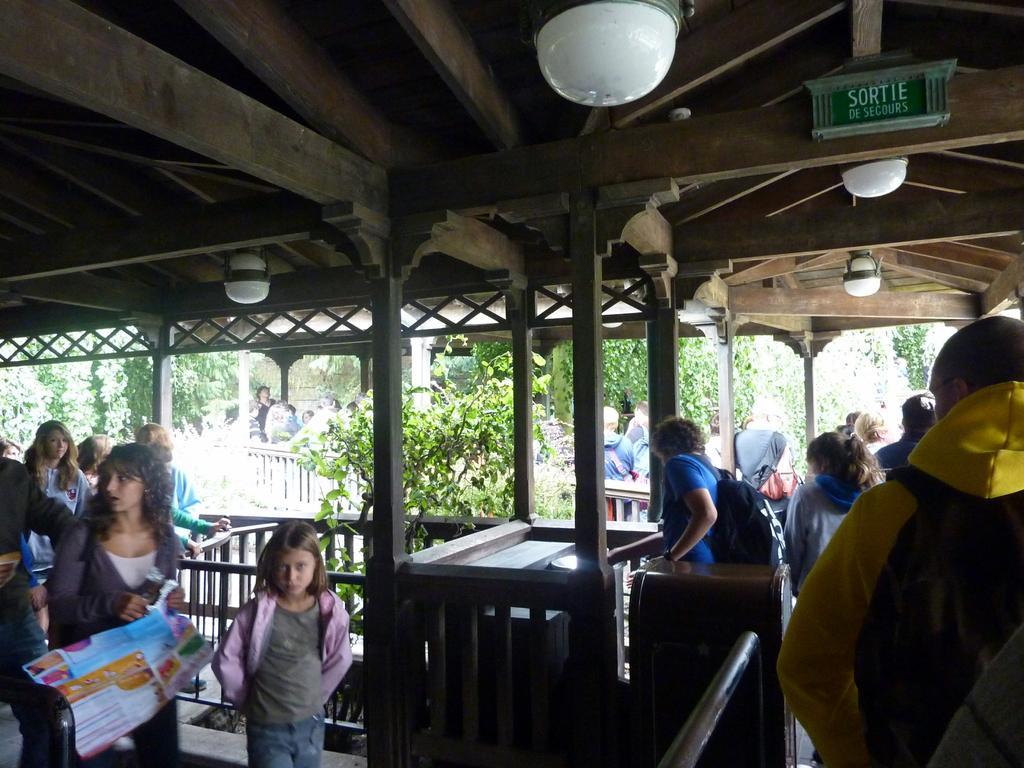In one or two sentences, can you explain what this image depicts? In this image, we can see persons wearing clothes. There are lights on the ceiling. There are trees in the middle of the image. 